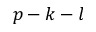<formula> <loc_0><loc_0><loc_500><loc_500>p - k - l</formula> 